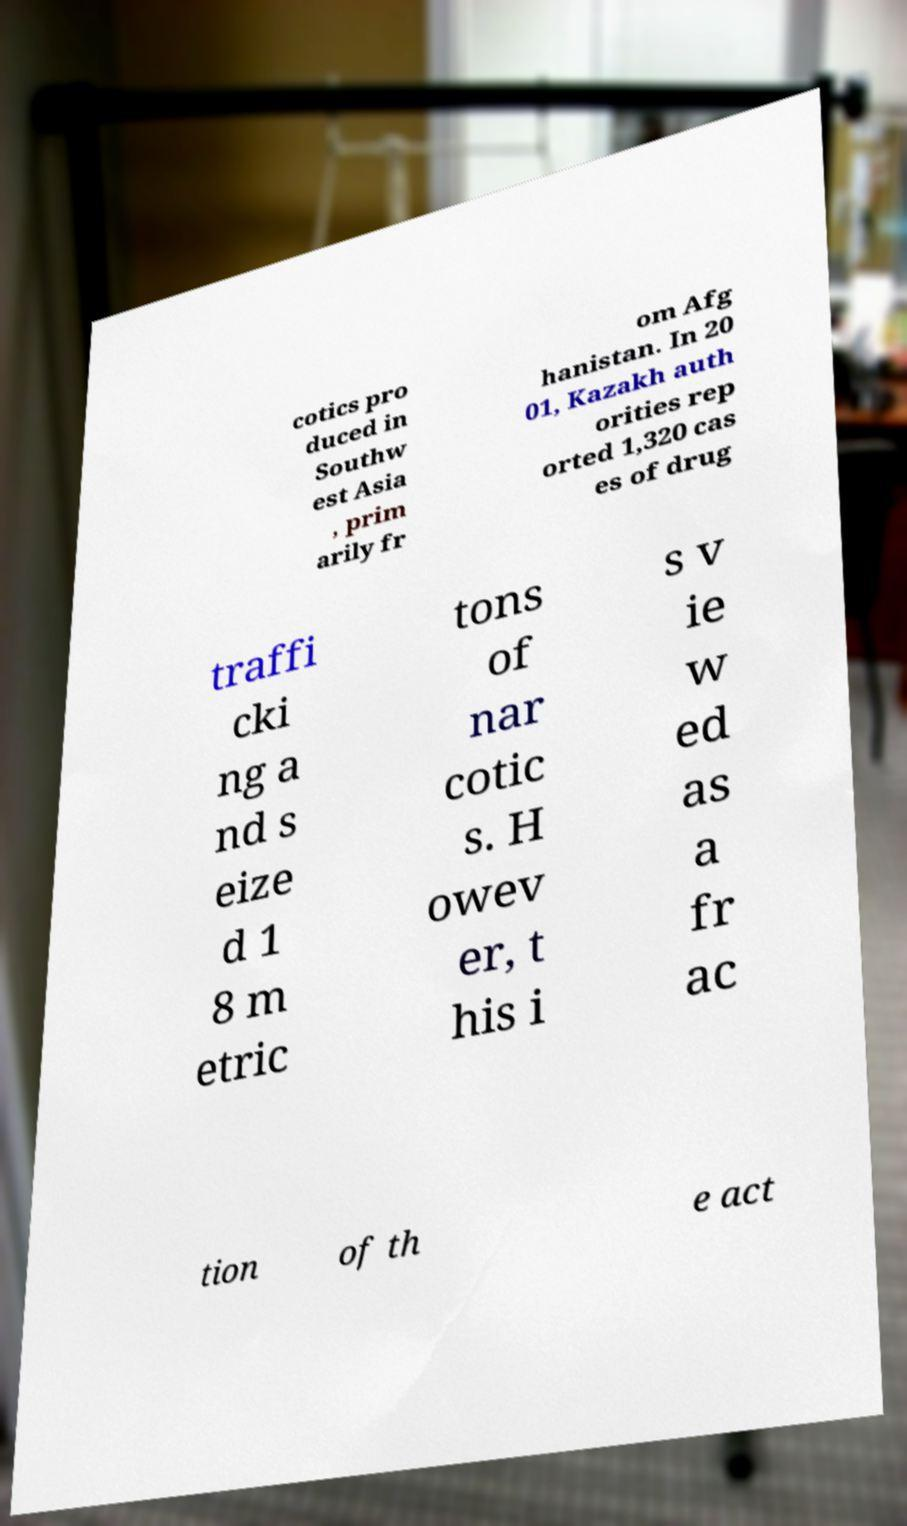Can you read and provide the text displayed in the image?This photo seems to have some interesting text. Can you extract and type it out for me? cotics pro duced in Southw est Asia , prim arily fr om Afg hanistan. In 20 01, Kazakh auth orities rep orted 1,320 cas es of drug traffi cki ng a nd s eize d 1 8 m etric tons of nar cotic s. H owev er, t his i s v ie w ed as a fr ac tion of th e act 